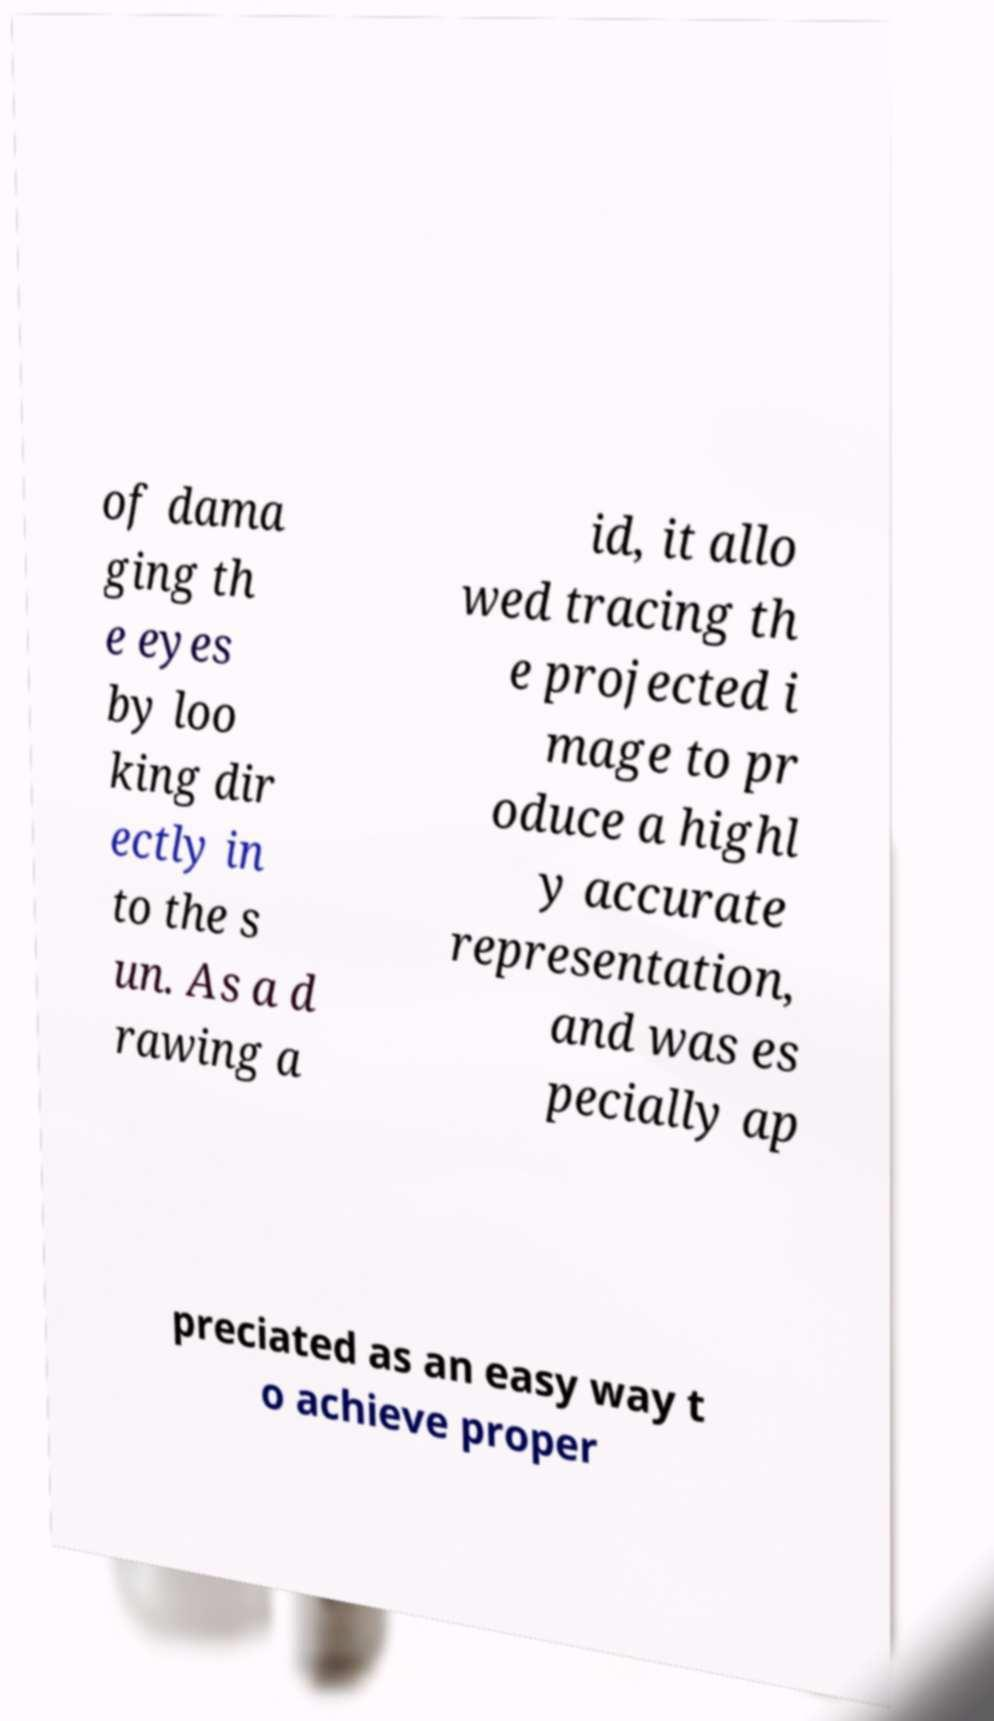Could you assist in decoding the text presented in this image and type it out clearly? of dama ging th e eyes by loo king dir ectly in to the s un. As a d rawing a id, it allo wed tracing th e projected i mage to pr oduce a highl y accurate representation, and was es pecially ap preciated as an easy way t o achieve proper 